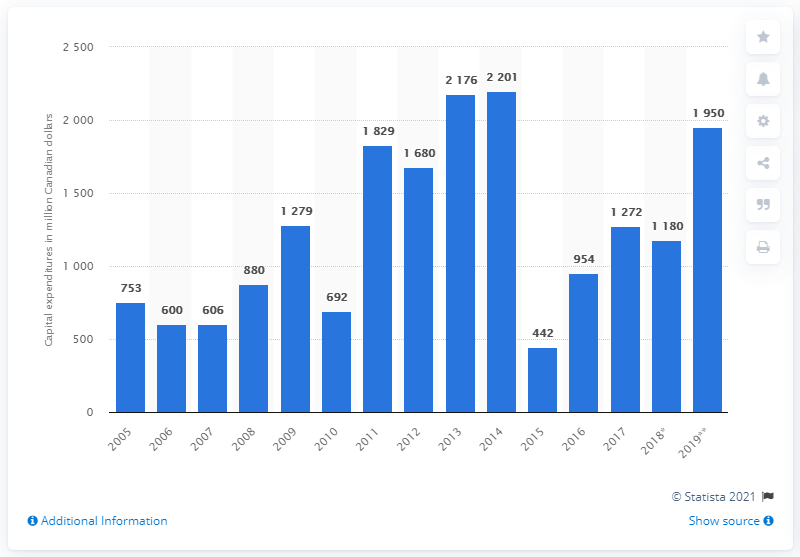Outline some significant characteristics in this image. In 2011, the industrial chemical industry invested a significant amount of money in capital expenditures, totaling 1,829. 